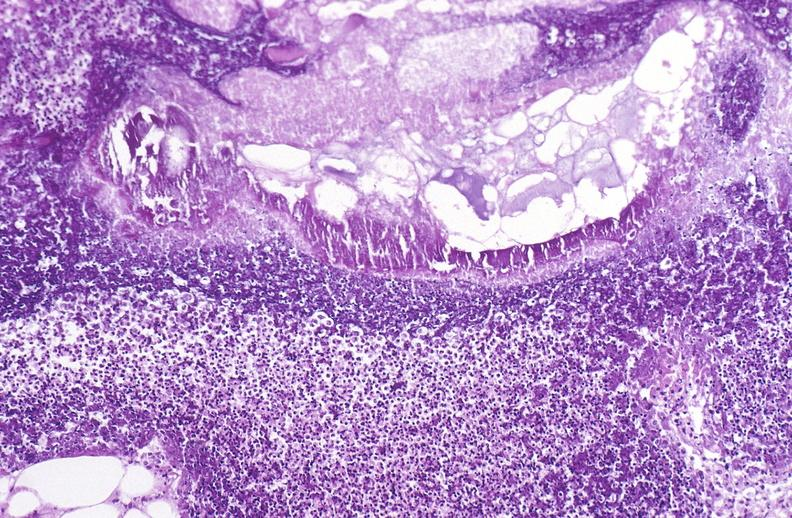does myocardial infarct show pancreatic fat necrosis?
Answer the question using a single word or phrase. No 